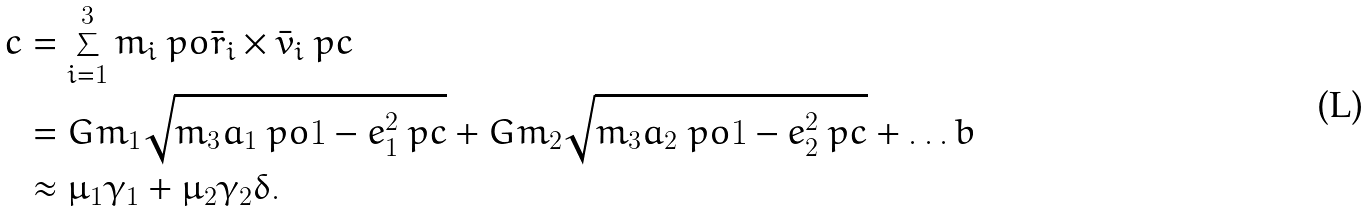<formula> <loc_0><loc_0><loc_500><loc_500>c & = \sum _ { i = 1 } ^ { 3 } m _ { i } \ p o \bar { r } _ { i } \times \bar { v } _ { i } \ p c \\ & = G m _ { 1 } \sqrt { m _ { 3 } a _ { 1 } \ p o 1 - e _ { 1 } ^ { 2 } \ p c } + G m _ { 2 } \sqrt { m _ { 3 } a _ { 2 } \ p o 1 - e _ { 2 } ^ { 2 } \ p c } + \dots b \\ & \approx \mu _ { 1 } \gamma _ { 1 } + \mu _ { 2 } \gamma _ { 2 } \delta .</formula> 